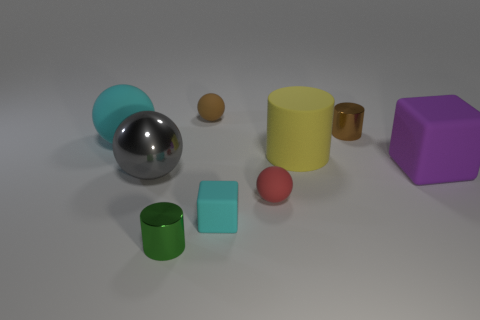Is the number of tiny cylinders that are right of the red thing greater than the number of green things on the left side of the gray ball?
Provide a short and direct response. Yes. Does the large ball to the right of the large cyan matte object have the same color as the tiny cylinder behind the red thing?
Your answer should be very brief. No. The green object that is the same size as the brown cylinder is what shape?
Offer a terse response. Cylinder. Is there a gray rubber object that has the same shape as the small red thing?
Your answer should be very brief. No. Is the material of the small brown object that is left of the big cylinder the same as the tiny cylinder that is behind the tiny cyan thing?
Ensure brevity in your answer.  No. There is a object that is the same color as the small matte cube; what is its shape?
Offer a terse response. Sphere. What number of big cyan objects have the same material as the yellow thing?
Offer a terse response. 1. What is the color of the big matte block?
Offer a terse response. Purple. There is a cyan thing behind the tiny red rubber sphere; is it the same shape as the brown thing right of the cyan matte block?
Provide a short and direct response. No. There is a matte object right of the tiny brown metallic cylinder; what is its color?
Keep it short and to the point. Purple. 